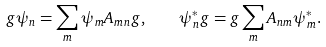Convert formula to latex. <formula><loc_0><loc_0><loc_500><loc_500>g \psi _ { n } = \sum _ { m } \psi _ { m } A _ { m n } g , \quad \psi ^ { * } _ { n } g = g \sum _ { m } A _ { n m } \psi ^ { * } _ { m } .</formula> 